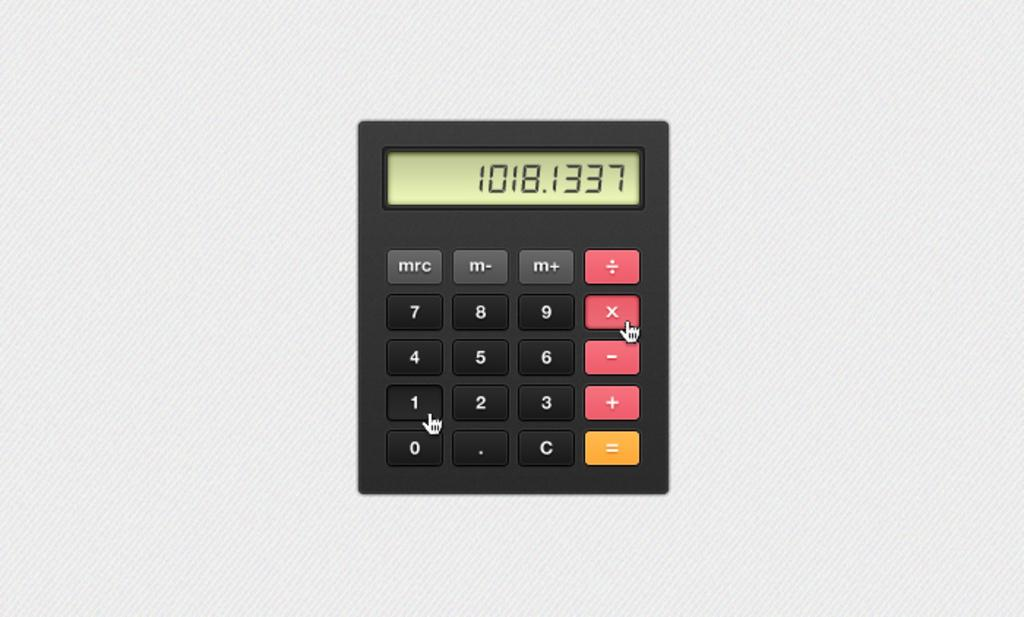<image>
Offer a succinct explanation of the picture presented. A calculator shows the number 1018.1337 on the screen. 